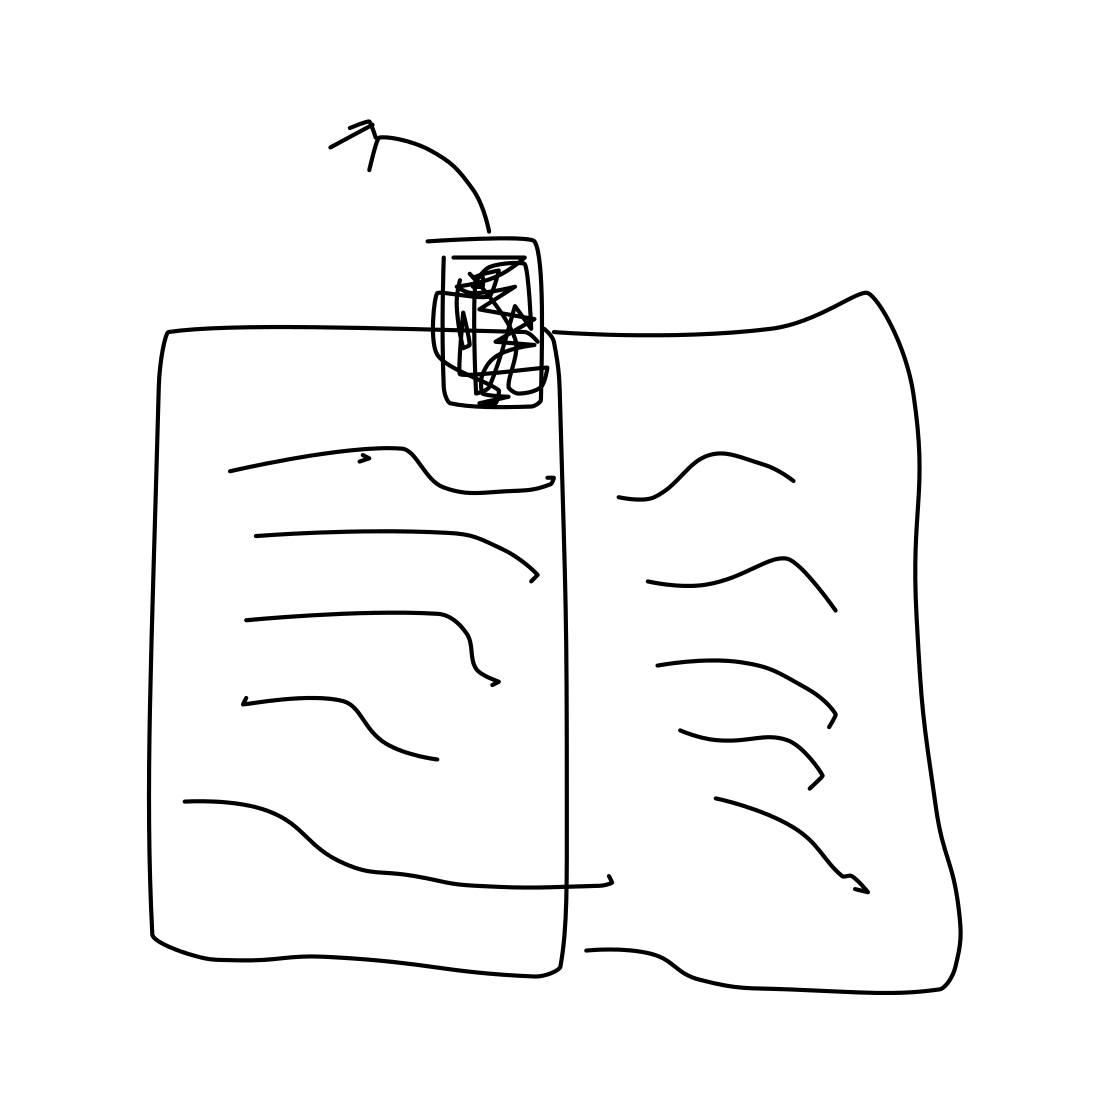In the scene, is a book in it? Indeed, there is a book depicted in the image. It appears to be open, lying flat, possibly indicating it is being read or was recently used. The contents of the pages are not clear, but they contain some kind of text or markings. 